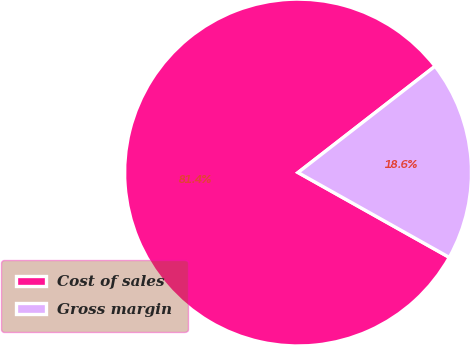<chart> <loc_0><loc_0><loc_500><loc_500><pie_chart><fcel>Cost of sales<fcel>Gross margin<nl><fcel>81.36%<fcel>18.64%<nl></chart> 